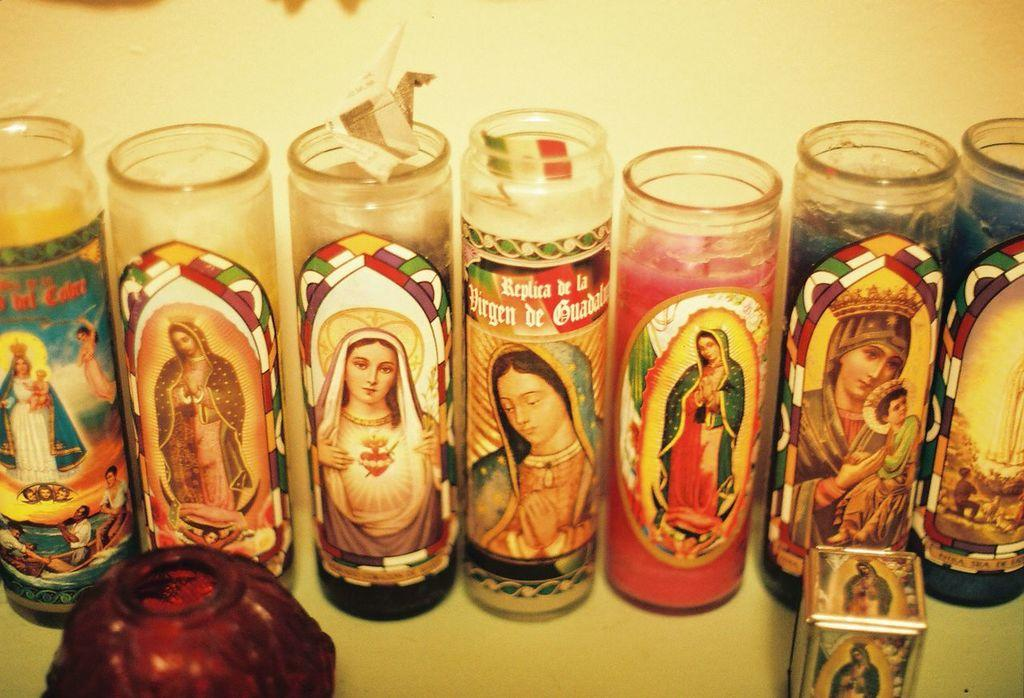What type of containers are visible in the image? There are glass bottles in the image. What can be seen on the glass bottles? The glass bottles have different pictures on them. How many nails are holding the giraffe in the image? There is no giraffe present in the image, and therefore no nails holding it. 